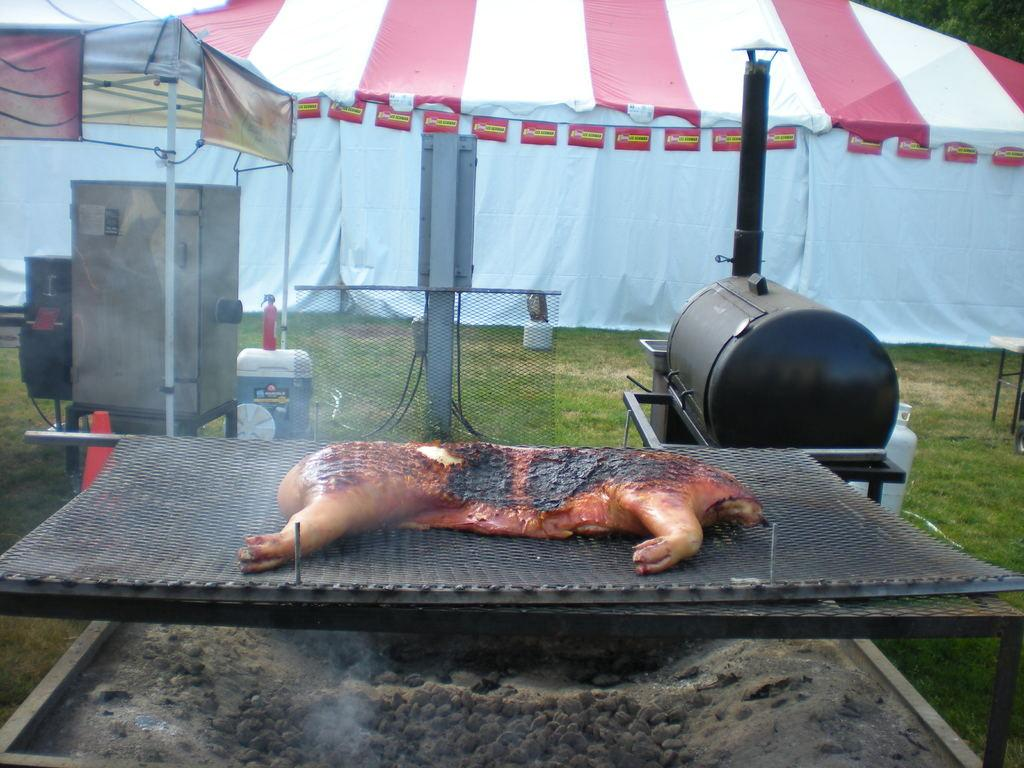What is being cooked on the grill in the image? There is meat on a grill in the image. What type of structure can be seen in the image? There is a mesh and poles in the image, which suggests a tent-like structure. Can you describe the tent in the image? There is a tent in the image, and trees are visible behind it. What type of marble is being used to decorate the library in the image? There is no library or marble present in the image. 